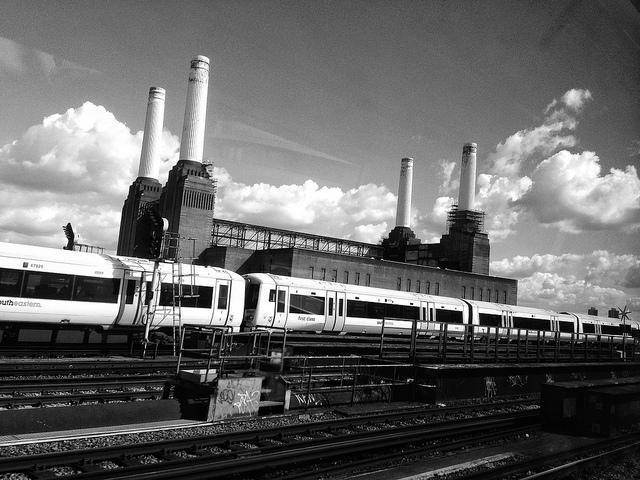How many smoke stacks are there?
Give a very brief answer. 4. How many trains are in the photo?
Give a very brief answer. 1. 